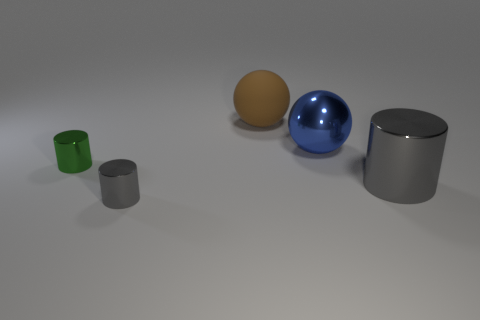What number of large cylinders have the same material as the large blue thing?
Your answer should be very brief. 1. What color is the small object that is the same material as the small green cylinder?
Your answer should be compact. Gray. What is the shape of the large blue thing?
Provide a short and direct response. Sphere. What is the material of the sphere that is behind the large blue thing?
Provide a succinct answer. Rubber. Are there any tiny metallic objects that have the same color as the big cylinder?
Your answer should be compact. Yes. The object that is the same size as the green shiny cylinder is what shape?
Give a very brief answer. Cylinder. There is a cylinder in front of the large gray object; what color is it?
Provide a succinct answer. Gray. There is a blue metallic thing right of the small green metallic object; is there a big object that is right of it?
Give a very brief answer. Yes. How many things are either tiny things that are behind the small gray cylinder or small green things?
Provide a short and direct response. 1. There is a big brown object right of the gray object to the left of the metallic ball; what is its material?
Give a very brief answer. Rubber. 